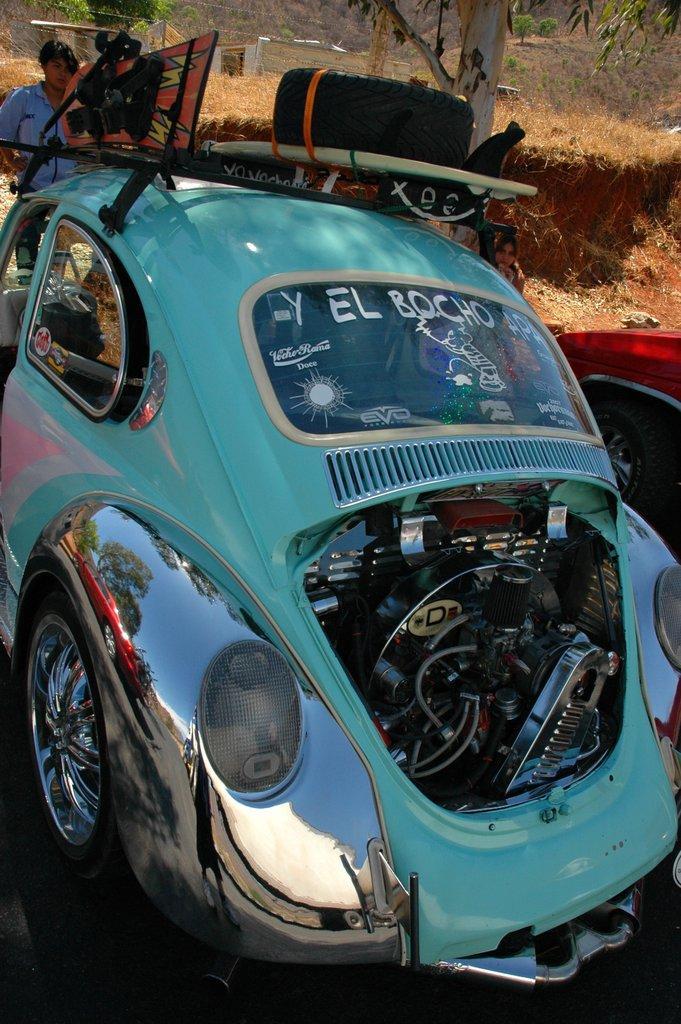Please provide a concise description of this image. In this image there is a car, there are objectś on the car, there is a person standing, there is a tree, there is grass, there is a red car truncated. 